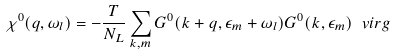Convert formula to latex. <formula><loc_0><loc_0><loc_500><loc_500>\chi ^ { 0 } ( { q } , \omega _ { l } ) = - \frac { T } { N _ { L } } \sum _ { { k } , m } G ^ { 0 } ( { k } + { q } , \epsilon _ { m } + \omega _ { l } ) G ^ { 0 } ( { k } , \epsilon _ { m } ) \ v i r g</formula> 